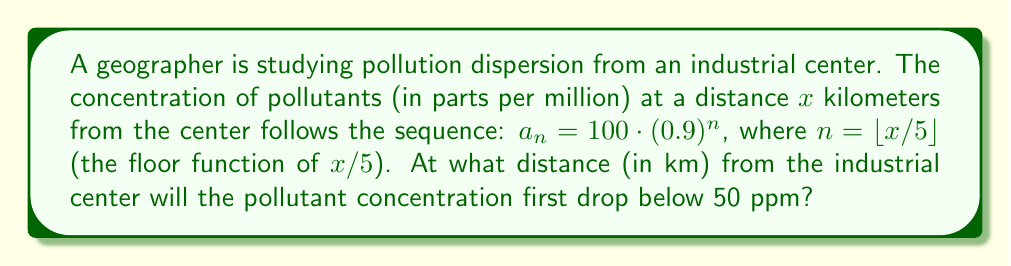Show me your answer to this math problem. To solve this problem, we need to follow these steps:

1) The concentration drops below 50 ppm when $a_n < 50$.

2) We need to solve the inequality:
   $$100 \cdot (0.9)^n < 50$$

3) Dividing both sides by 100:
   $$(0.9)^n < 0.5$$

4) Taking the natural log of both sides:
   $$n \cdot \ln(0.9) < \ln(0.5)$$

5) Dividing both sides by $\ln(0.9)$ (note that $\ln(0.9)$ is negative, so the inequality sign flips):
   $$n > \frac{\ln(0.5)}{\ln(0.9)} \approx 6.58$$

6) Since $n$ must be an integer (due to the floor function), the smallest value of $n$ that satisfies this inequality is 7.

7) Recall that $n = \lfloor x/5 \rfloor$. For $n$ to be 7, we need:
   $$7 \leq x/5 < 8$$

8) Multiplying all parts by 5:
   $$35 \leq x < 40$$

9) The smallest integer $x$ that satisfies this is 35.

Therefore, the pollutant concentration will first drop below 50 ppm at a distance of 35 km from the industrial center.
Answer: 35 km 